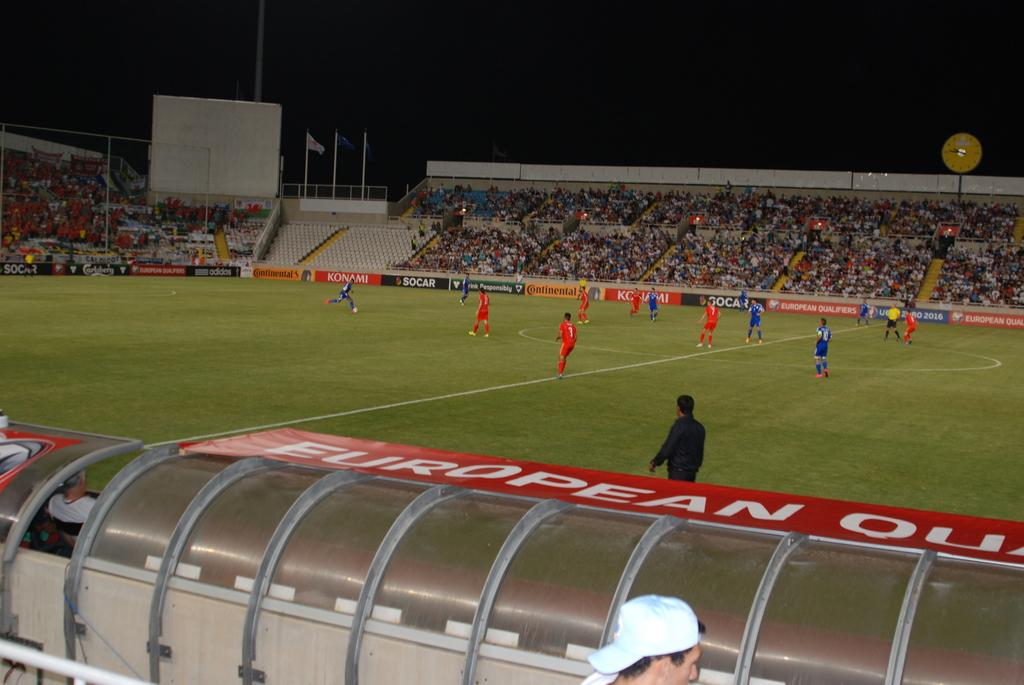<image>
Write a terse but informative summary of the picture. a soccer field with a sign on the sidelines that says 'european' 